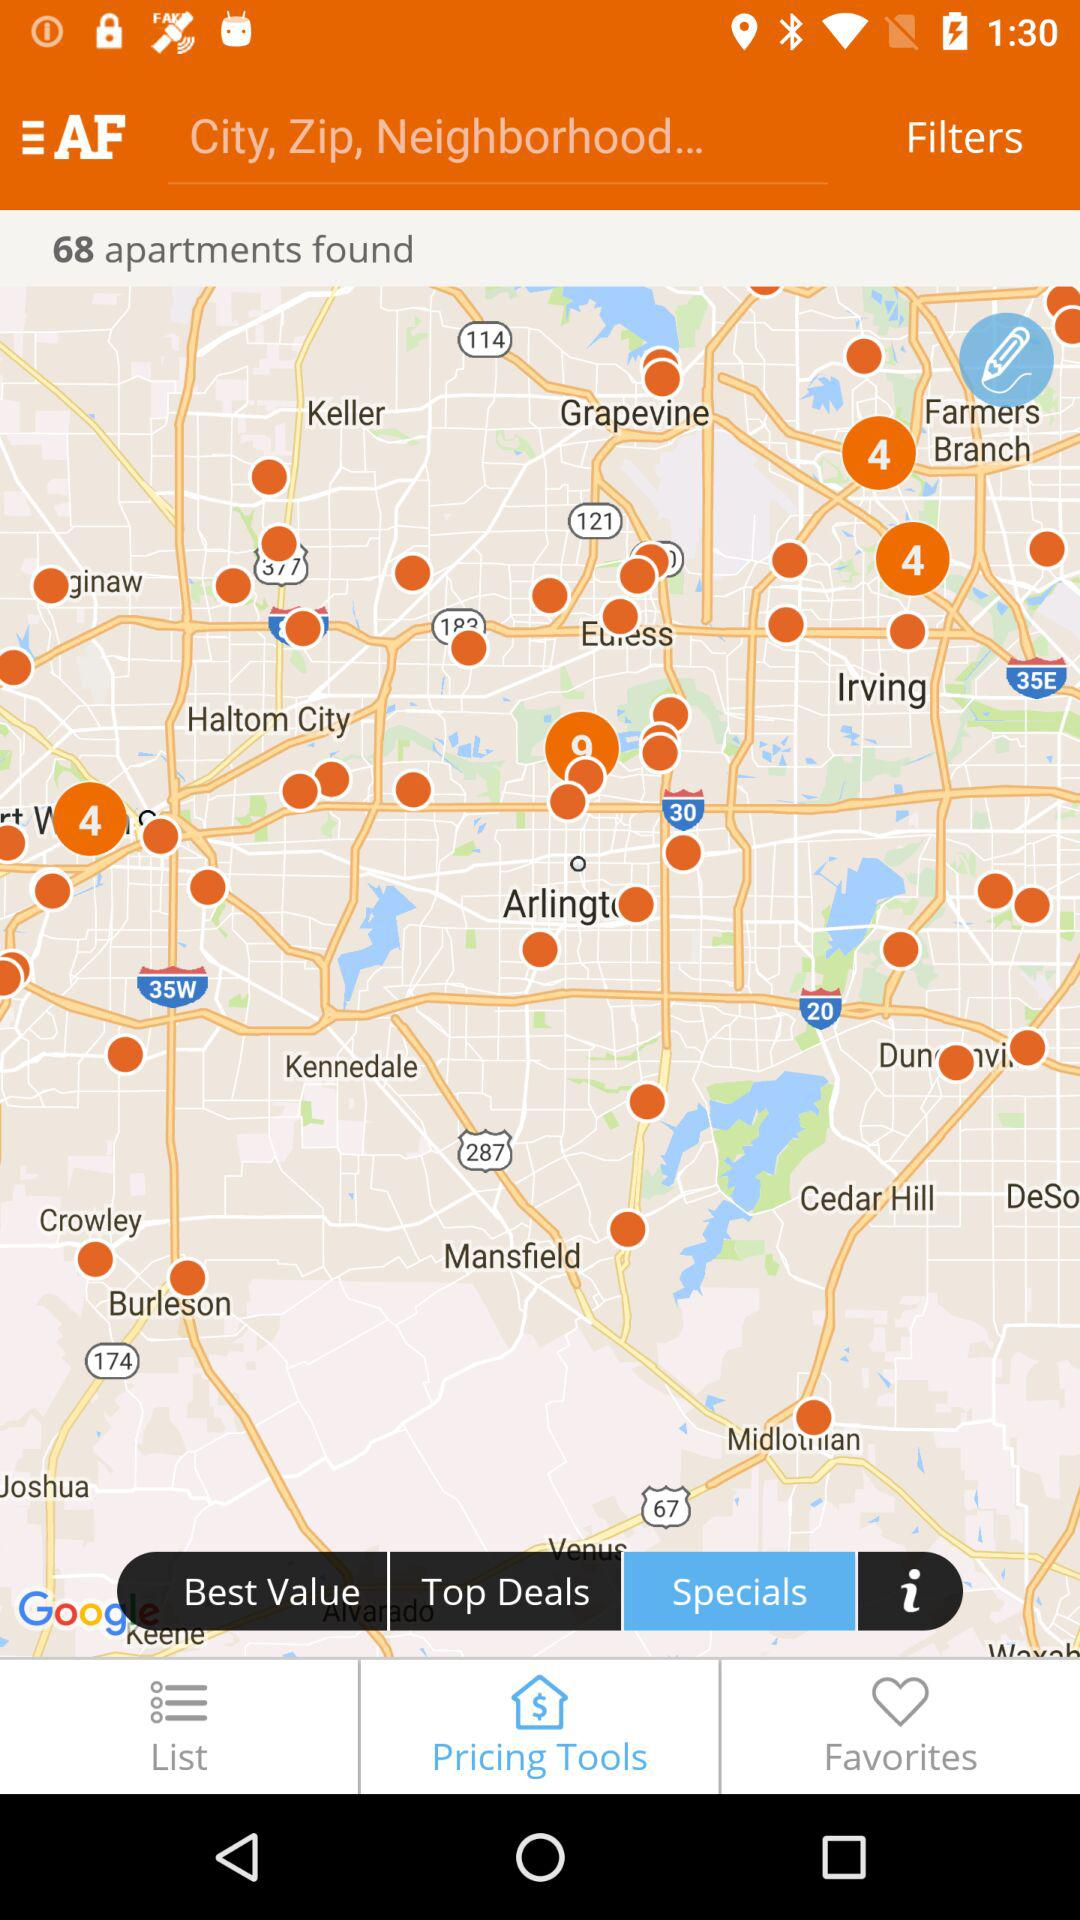Which tab is selected? The selected tabs are "Specials" and "Pricing Tools". 